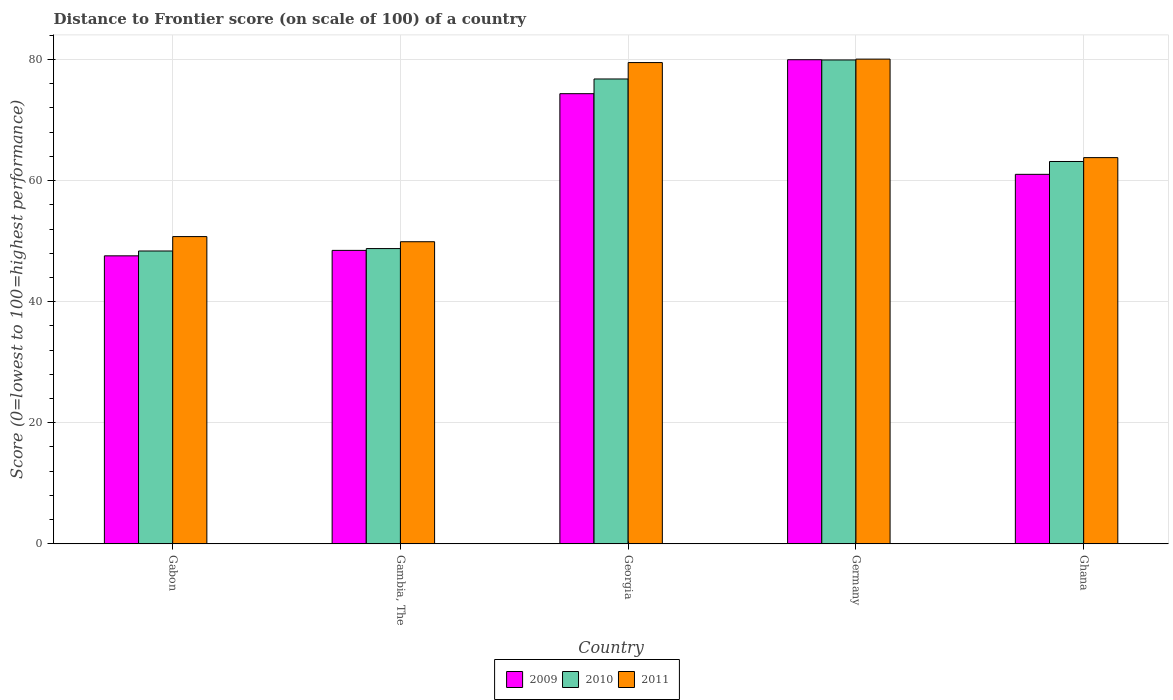How many bars are there on the 3rd tick from the left?
Keep it short and to the point. 3. What is the label of the 1st group of bars from the left?
Your response must be concise. Gabon. What is the distance to frontier score of in 2009 in Gambia, The?
Your answer should be very brief. 48.47. Across all countries, what is the maximum distance to frontier score of in 2010?
Provide a short and direct response. 79.92. Across all countries, what is the minimum distance to frontier score of in 2010?
Your answer should be compact. 48.37. In which country was the distance to frontier score of in 2011 minimum?
Your answer should be compact. Gambia, The. What is the total distance to frontier score of in 2010 in the graph?
Your answer should be very brief. 316.99. What is the difference between the distance to frontier score of in 2011 in Gambia, The and that in Germany?
Give a very brief answer. -30.16. What is the difference between the distance to frontier score of in 2011 in Ghana and the distance to frontier score of in 2010 in Gabon?
Your response must be concise. 15.42. What is the average distance to frontier score of in 2010 per country?
Your answer should be compact. 63.4. What is the difference between the distance to frontier score of of/in 2009 and distance to frontier score of of/in 2011 in Ghana?
Your answer should be compact. -2.76. In how many countries, is the distance to frontier score of in 2010 greater than 32?
Provide a short and direct response. 5. What is the ratio of the distance to frontier score of in 2010 in Georgia to that in Germany?
Make the answer very short. 0.96. Is the difference between the distance to frontier score of in 2009 in Gabon and Ghana greater than the difference between the distance to frontier score of in 2011 in Gabon and Ghana?
Provide a short and direct response. No. What is the difference between the highest and the second highest distance to frontier score of in 2011?
Give a very brief answer. 16.27. What is the difference between the highest and the lowest distance to frontier score of in 2009?
Your answer should be compact. 32.39. In how many countries, is the distance to frontier score of in 2009 greater than the average distance to frontier score of in 2009 taken over all countries?
Offer a terse response. 2. What does the 1st bar from the right in Gabon represents?
Give a very brief answer. 2011. How many bars are there?
Your answer should be very brief. 15. How many countries are there in the graph?
Your answer should be compact. 5. Are the values on the major ticks of Y-axis written in scientific E-notation?
Make the answer very short. No. Does the graph contain any zero values?
Your response must be concise. No. Does the graph contain grids?
Offer a terse response. Yes. How are the legend labels stacked?
Your answer should be compact. Horizontal. What is the title of the graph?
Your answer should be compact. Distance to Frontier score (on scale of 100) of a country. Does "2012" appear as one of the legend labels in the graph?
Your answer should be compact. No. What is the label or title of the Y-axis?
Make the answer very short. Score (0=lowest to 100=highest performance). What is the Score (0=lowest to 100=highest performance) of 2009 in Gabon?
Provide a short and direct response. 47.57. What is the Score (0=lowest to 100=highest performance) of 2010 in Gabon?
Provide a succinct answer. 48.37. What is the Score (0=lowest to 100=highest performance) of 2011 in Gabon?
Give a very brief answer. 50.75. What is the Score (0=lowest to 100=highest performance) of 2009 in Gambia, The?
Your answer should be very brief. 48.47. What is the Score (0=lowest to 100=highest performance) in 2010 in Gambia, The?
Your answer should be compact. 48.77. What is the Score (0=lowest to 100=highest performance) of 2011 in Gambia, The?
Your answer should be very brief. 49.9. What is the Score (0=lowest to 100=highest performance) of 2009 in Georgia?
Your answer should be very brief. 74.35. What is the Score (0=lowest to 100=highest performance) in 2010 in Georgia?
Provide a short and direct response. 76.78. What is the Score (0=lowest to 100=highest performance) in 2011 in Georgia?
Provide a short and direct response. 79.49. What is the Score (0=lowest to 100=highest performance) in 2009 in Germany?
Your response must be concise. 79.96. What is the Score (0=lowest to 100=highest performance) in 2010 in Germany?
Your answer should be very brief. 79.92. What is the Score (0=lowest to 100=highest performance) in 2011 in Germany?
Your response must be concise. 80.06. What is the Score (0=lowest to 100=highest performance) in 2009 in Ghana?
Give a very brief answer. 61.03. What is the Score (0=lowest to 100=highest performance) of 2010 in Ghana?
Your response must be concise. 63.15. What is the Score (0=lowest to 100=highest performance) in 2011 in Ghana?
Give a very brief answer. 63.79. Across all countries, what is the maximum Score (0=lowest to 100=highest performance) in 2009?
Your answer should be very brief. 79.96. Across all countries, what is the maximum Score (0=lowest to 100=highest performance) of 2010?
Offer a very short reply. 79.92. Across all countries, what is the maximum Score (0=lowest to 100=highest performance) in 2011?
Ensure brevity in your answer.  80.06. Across all countries, what is the minimum Score (0=lowest to 100=highest performance) of 2009?
Your answer should be very brief. 47.57. Across all countries, what is the minimum Score (0=lowest to 100=highest performance) of 2010?
Provide a short and direct response. 48.37. Across all countries, what is the minimum Score (0=lowest to 100=highest performance) in 2011?
Offer a very short reply. 49.9. What is the total Score (0=lowest to 100=highest performance) of 2009 in the graph?
Your answer should be very brief. 311.38. What is the total Score (0=lowest to 100=highest performance) in 2010 in the graph?
Your answer should be compact. 316.99. What is the total Score (0=lowest to 100=highest performance) of 2011 in the graph?
Offer a terse response. 323.99. What is the difference between the Score (0=lowest to 100=highest performance) of 2010 in Gabon and that in Gambia, The?
Offer a terse response. -0.4. What is the difference between the Score (0=lowest to 100=highest performance) in 2011 in Gabon and that in Gambia, The?
Offer a terse response. 0.85. What is the difference between the Score (0=lowest to 100=highest performance) of 2009 in Gabon and that in Georgia?
Give a very brief answer. -26.78. What is the difference between the Score (0=lowest to 100=highest performance) of 2010 in Gabon and that in Georgia?
Your answer should be compact. -28.41. What is the difference between the Score (0=lowest to 100=highest performance) in 2011 in Gabon and that in Georgia?
Keep it short and to the point. -28.74. What is the difference between the Score (0=lowest to 100=highest performance) in 2009 in Gabon and that in Germany?
Your answer should be very brief. -32.39. What is the difference between the Score (0=lowest to 100=highest performance) of 2010 in Gabon and that in Germany?
Your response must be concise. -31.55. What is the difference between the Score (0=lowest to 100=highest performance) in 2011 in Gabon and that in Germany?
Your answer should be very brief. -29.31. What is the difference between the Score (0=lowest to 100=highest performance) in 2009 in Gabon and that in Ghana?
Give a very brief answer. -13.46. What is the difference between the Score (0=lowest to 100=highest performance) in 2010 in Gabon and that in Ghana?
Your response must be concise. -14.78. What is the difference between the Score (0=lowest to 100=highest performance) in 2011 in Gabon and that in Ghana?
Make the answer very short. -13.04. What is the difference between the Score (0=lowest to 100=highest performance) in 2009 in Gambia, The and that in Georgia?
Keep it short and to the point. -25.88. What is the difference between the Score (0=lowest to 100=highest performance) in 2010 in Gambia, The and that in Georgia?
Give a very brief answer. -28.01. What is the difference between the Score (0=lowest to 100=highest performance) of 2011 in Gambia, The and that in Georgia?
Your answer should be compact. -29.59. What is the difference between the Score (0=lowest to 100=highest performance) of 2009 in Gambia, The and that in Germany?
Your answer should be very brief. -31.49. What is the difference between the Score (0=lowest to 100=highest performance) of 2010 in Gambia, The and that in Germany?
Your response must be concise. -31.15. What is the difference between the Score (0=lowest to 100=highest performance) of 2011 in Gambia, The and that in Germany?
Provide a short and direct response. -30.16. What is the difference between the Score (0=lowest to 100=highest performance) in 2009 in Gambia, The and that in Ghana?
Provide a succinct answer. -12.56. What is the difference between the Score (0=lowest to 100=highest performance) of 2010 in Gambia, The and that in Ghana?
Make the answer very short. -14.38. What is the difference between the Score (0=lowest to 100=highest performance) in 2011 in Gambia, The and that in Ghana?
Provide a succinct answer. -13.89. What is the difference between the Score (0=lowest to 100=highest performance) of 2009 in Georgia and that in Germany?
Offer a very short reply. -5.61. What is the difference between the Score (0=lowest to 100=highest performance) of 2010 in Georgia and that in Germany?
Your answer should be compact. -3.14. What is the difference between the Score (0=lowest to 100=highest performance) in 2011 in Georgia and that in Germany?
Give a very brief answer. -0.57. What is the difference between the Score (0=lowest to 100=highest performance) of 2009 in Georgia and that in Ghana?
Your response must be concise. 13.32. What is the difference between the Score (0=lowest to 100=highest performance) in 2010 in Georgia and that in Ghana?
Offer a terse response. 13.63. What is the difference between the Score (0=lowest to 100=highest performance) of 2009 in Germany and that in Ghana?
Your response must be concise. 18.93. What is the difference between the Score (0=lowest to 100=highest performance) in 2010 in Germany and that in Ghana?
Offer a very short reply. 16.77. What is the difference between the Score (0=lowest to 100=highest performance) in 2011 in Germany and that in Ghana?
Offer a very short reply. 16.27. What is the difference between the Score (0=lowest to 100=highest performance) of 2009 in Gabon and the Score (0=lowest to 100=highest performance) of 2010 in Gambia, The?
Provide a short and direct response. -1.2. What is the difference between the Score (0=lowest to 100=highest performance) of 2009 in Gabon and the Score (0=lowest to 100=highest performance) of 2011 in Gambia, The?
Make the answer very short. -2.33. What is the difference between the Score (0=lowest to 100=highest performance) in 2010 in Gabon and the Score (0=lowest to 100=highest performance) in 2011 in Gambia, The?
Provide a short and direct response. -1.53. What is the difference between the Score (0=lowest to 100=highest performance) in 2009 in Gabon and the Score (0=lowest to 100=highest performance) in 2010 in Georgia?
Offer a very short reply. -29.21. What is the difference between the Score (0=lowest to 100=highest performance) in 2009 in Gabon and the Score (0=lowest to 100=highest performance) in 2011 in Georgia?
Your answer should be compact. -31.92. What is the difference between the Score (0=lowest to 100=highest performance) in 2010 in Gabon and the Score (0=lowest to 100=highest performance) in 2011 in Georgia?
Your answer should be very brief. -31.12. What is the difference between the Score (0=lowest to 100=highest performance) of 2009 in Gabon and the Score (0=lowest to 100=highest performance) of 2010 in Germany?
Keep it short and to the point. -32.35. What is the difference between the Score (0=lowest to 100=highest performance) of 2009 in Gabon and the Score (0=lowest to 100=highest performance) of 2011 in Germany?
Your response must be concise. -32.49. What is the difference between the Score (0=lowest to 100=highest performance) of 2010 in Gabon and the Score (0=lowest to 100=highest performance) of 2011 in Germany?
Ensure brevity in your answer.  -31.69. What is the difference between the Score (0=lowest to 100=highest performance) in 2009 in Gabon and the Score (0=lowest to 100=highest performance) in 2010 in Ghana?
Offer a terse response. -15.58. What is the difference between the Score (0=lowest to 100=highest performance) of 2009 in Gabon and the Score (0=lowest to 100=highest performance) of 2011 in Ghana?
Make the answer very short. -16.22. What is the difference between the Score (0=lowest to 100=highest performance) in 2010 in Gabon and the Score (0=lowest to 100=highest performance) in 2011 in Ghana?
Your answer should be very brief. -15.42. What is the difference between the Score (0=lowest to 100=highest performance) of 2009 in Gambia, The and the Score (0=lowest to 100=highest performance) of 2010 in Georgia?
Provide a succinct answer. -28.31. What is the difference between the Score (0=lowest to 100=highest performance) of 2009 in Gambia, The and the Score (0=lowest to 100=highest performance) of 2011 in Georgia?
Your response must be concise. -31.02. What is the difference between the Score (0=lowest to 100=highest performance) of 2010 in Gambia, The and the Score (0=lowest to 100=highest performance) of 2011 in Georgia?
Give a very brief answer. -30.72. What is the difference between the Score (0=lowest to 100=highest performance) of 2009 in Gambia, The and the Score (0=lowest to 100=highest performance) of 2010 in Germany?
Ensure brevity in your answer.  -31.45. What is the difference between the Score (0=lowest to 100=highest performance) in 2009 in Gambia, The and the Score (0=lowest to 100=highest performance) in 2011 in Germany?
Give a very brief answer. -31.59. What is the difference between the Score (0=lowest to 100=highest performance) in 2010 in Gambia, The and the Score (0=lowest to 100=highest performance) in 2011 in Germany?
Offer a very short reply. -31.29. What is the difference between the Score (0=lowest to 100=highest performance) in 2009 in Gambia, The and the Score (0=lowest to 100=highest performance) in 2010 in Ghana?
Your response must be concise. -14.68. What is the difference between the Score (0=lowest to 100=highest performance) in 2009 in Gambia, The and the Score (0=lowest to 100=highest performance) in 2011 in Ghana?
Offer a very short reply. -15.32. What is the difference between the Score (0=lowest to 100=highest performance) in 2010 in Gambia, The and the Score (0=lowest to 100=highest performance) in 2011 in Ghana?
Make the answer very short. -15.02. What is the difference between the Score (0=lowest to 100=highest performance) of 2009 in Georgia and the Score (0=lowest to 100=highest performance) of 2010 in Germany?
Keep it short and to the point. -5.57. What is the difference between the Score (0=lowest to 100=highest performance) of 2009 in Georgia and the Score (0=lowest to 100=highest performance) of 2011 in Germany?
Make the answer very short. -5.71. What is the difference between the Score (0=lowest to 100=highest performance) in 2010 in Georgia and the Score (0=lowest to 100=highest performance) in 2011 in Germany?
Offer a very short reply. -3.28. What is the difference between the Score (0=lowest to 100=highest performance) in 2009 in Georgia and the Score (0=lowest to 100=highest performance) in 2011 in Ghana?
Ensure brevity in your answer.  10.56. What is the difference between the Score (0=lowest to 100=highest performance) of 2010 in Georgia and the Score (0=lowest to 100=highest performance) of 2011 in Ghana?
Your answer should be compact. 12.99. What is the difference between the Score (0=lowest to 100=highest performance) in 2009 in Germany and the Score (0=lowest to 100=highest performance) in 2010 in Ghana?
Give a very brief answer. 16.81. What is the difference between the Score (0=lowest to 100=highest performance) in 2009 in Germany and the Score (0=lowest to 100=highest performance) in 2011 in Ghana?
Provide a short and direct response. 16.17. What is the difference between the Score (0=lowest to 100=highest performance) of 2010 in Germany and the Score (0=lowest to 100=highest performance) of 2011 in Ghana?
Ensure brevity in your answer.  16.13. What is the average Score (0=lowest to 100=highest performance) of 2009 per country?
Ensure brevity in your answer.  62.28. What is the average Score (0=lowest to 100=highest performance) in 2010 per country?
Give a very brief answer. 63.4. What is the average Score (0=lowest to 100=highest performance) in 2011 per country?
Provide a succinct answer. 64.8. What is the difference between the Score (0=lowest to 100=highest performance) of 2009 and Score (0=lowest to 100=highest performance) of 2011 in Gabon?
Your response must be concise. -3.18. What is the difference between the Score (0=lowest to 100=highest performance) of 2010 and Score (0=lowest to 100=highest performance) of 2011 in Gabon?
Give a very brief answer. -2.38. What is the difference between the Score (0=lowest to 100=highest performance) of 2009 and Score (0=lowest to 100=highest performance) of 2011 in Gambia, The?
Keep it short and to the point. -1.43. What is the difference between the Score (0=lowest to 100=highest performance) in 2010 and Score (0=lowest to 100=highest performance) in 2011 in Gambia, The?
Your response must be concise. -1.13. What is the difference between the Score (0=lowest to 100=highest performance) in 2009 and Score (0=lowest to 100=highest performance) in 2010 in Georgia?
Ensure brevity in your answer.  -2.43. What is the difference between the Score (0=lowest to 100=highest performance) of 2009 and Score (0=lowest to 100=highest performance) of 2011 in Georgia?
Make the answer very short. -5.14. What is the difference between the Score (0=lowest to 100=highest performance) in 2010 and Score (0=lowest to 100=highest performance) in 2011 in Georgia?
Your response must be concise. -2.71. What is the difference between the Score (0=lowest to 100=highest performance) in 2010 and Score (0=lowest to 100=highest performance) in 2011 in Germany?
Offer a very short reply. -0.14. What is the difference between the Score (0=lowest to 100=highest performance) in 2009 and Score (0=lowest to 100=highest performance) in 2010 in Ghana?
Your answer should be very brief. -2.12. What is the difference between the Score (0=lowest to 100=highest performance) of 2009 and Score (0=lowest to 100=highest performance) of 2011 in Ghana?
Offer a terse response. -2.76. What is the difference between the Score (0=lowest to 100=highest performance) in 2010 and Score (0=lowest to 100=highest performance) in 2011 in Ghana?
Make the answer very short. -0.64. What is the ratio of the Score (0=lowest to 100=highest performance) in 2009 in Gabon to that in Gambia, The?
Make the answer very short. 0.98. What is the ratio of the Score (0=lowest to 100=highest performance) in 2010 in Gabon to that in Gambia, The?
Your response must be concise. 0.99. What is the ratio of the Score (0=lowest to 100=highest performance) in 2009 in Gabon to that in Georgia?
Give a very brief answer. 0.64. What is the ratio of the Score (0=lowest to 100=highest performance) of 2010 in Gabon to that in Georgia?
Offer a terse response. 0.63. What is the ratio of the Score (0=lowest to 100=highest performance) of 2011 in Gabon to that in Georgia?
Offer a very short reply. 0.64. What is the ratio of the Score (0=lowest to 100=highest performance) in 2009 in Gabon to that in Germany?
Give a very brief answer. 0.59. What is the ratio of the Score (0=lowest to 100=highest performance) of 2010 in Gabon to that in Germany?
Provide a succinct answer. 0.61. What is the ratio of the Score (0=lowest to 100=highest performance) of 2011 in Gabon to that in Germany?
Offer a terse response. 0.63. What is the ratio of the Score (0=lowest to 100=highest performance) of 2009 in Gabon to that in Ghana?
Keep it short and to the point. 0.78. What is the ratio of the Score (0=lowest to 100=highest performance) in 2010 in Gabon to that in Ghana?
Your answer should be very brief. 0.77. What is the ratio of the Score (0=lowest to 100=highest performance) of 2011 in Gabon to that in Ghana?
Keep it short and to the point. 0.8. What is the ratio of the Score (0=lowest to 100=highest performance) in 2009 in Gambia, The to that in Georgia?
Ensure brevity in your answer.  0.65. What is the ratio of the Score (0=lowest to 100=highest performance) of 2010 in Gambia, The to that in Georgia?
Offer a very short reply. 0.64. What is the ratio of the Score (0=lowest to 100=highest performance) in 2011 in Gambia, The to that in Georgia?
Provide a short and direct response. 0.63. What is the ratio of the Score (0=lowest to 100=highest performance) in 2009 in Gambia, The to that in Germany?
Give a very brief answer. 0.61. What is the ratio of the Score (0=lowest to 100=highest performance) of 2010 in Gambia, The to that in Germany?
Give a very brief answer. 0.61. What is the ratio of the Score (0=lowest to 100=highest performance) in 2011 in Gambia, The to that in Germany?
Give a very brief answer. 0.62. What is the ratio of the Score (0=lowest to 100=highest performance) of 2009 in Gambia, The to that in Ghana?
Make the answer very short. 0.79. What is the ratio of the Score (0=lowest to 100=highest performance) of 2010 in Gambia, The to that in Ghana?
Provide a succinct answer. 0.77. What is the ratio of the Score (0=lowest to 100=highest performance) of 2011 in Gambia, The to that in Ghana?
Make the answer very short. 0.78. What is the ratio of the Score (0=lowest to 100=highest performance) in 2009 in Georgia to that in Germany?
Provide a succinct answer. 0.93. What is the ratio of the Score (0=lowest to 100=highest performance) in 2010 in Georgia to that in Germany?
Your response must be concise. 0.96. What is the ratio of the Score (0=lowest to 100=highest performance) of 2011 in Georgia to that in Germany?
Your answer should be compact. 0.99. What is the ratio of the Score (0=lowest to 100=highest performance) of 2009 in Georgia to that in Ghana?
Your answer should be compact. 1.22. What is the ratio of the Score (0=lowest to 100=highest performance) in 2010 in Georgia to that in Ghana?
Keep it short and to the point. 1.22. What is the ratio of the Score (0=lowest to 100=highest performance) in 2011 in Georgia to that in Ghana?
Give a very brief answer. 1.25. What is the ratio of the Score (0=lowest to 100=highest performance) in 2009 in Germany to that in Ghana?
Offer a terse response. 1.31. What is the ratio of the Score (0=lowest to 100=highest performance) in 2010 in Germany to that in Ghana?
Your response must be concise. 1.27. What is the ratio of the Score (0=lowest to 100=highest performance) in 2011 in Germany to that in Ghana?
Make the answer very short. 1.26. What is the difference between the highest and the second highest Score (0=lowest to 100=highest performance) in 2009?
Offer a terse response. 5.61. What is the difference between the highest and the second highest Score (0=lowest to 100=highest performance) of 2010?
Ensure brevity in your answer.  3.14. What is the difference between the highest and the second highest Score (0=lowest to 100=highest performance) in 2011?
Your response must be concise. 0.57. What is the difference between the highest and the lowest Score (0=lowest to 100=highest performance) of 2009?
Provide a short and direct response. 32.39. What is the difference between the highest and the lowest Score (0=lowest to 100=highest performance) of 2010?
Provide a succinct answer. 31.55. What is the difference between the highest and the lowest Score (0=lowest to 100=highest performance) in 2011?
Ensure brevity in your answer.  30.16. 